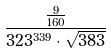<formula> <loc_0><loc_0><loc_500><loc_500>\frac { \frac { 9 } { 1 6 0 } } { 3 2 3 ^ { 3 3 9 } \cdot \sqrt { 3 8 3 } }</formula> 